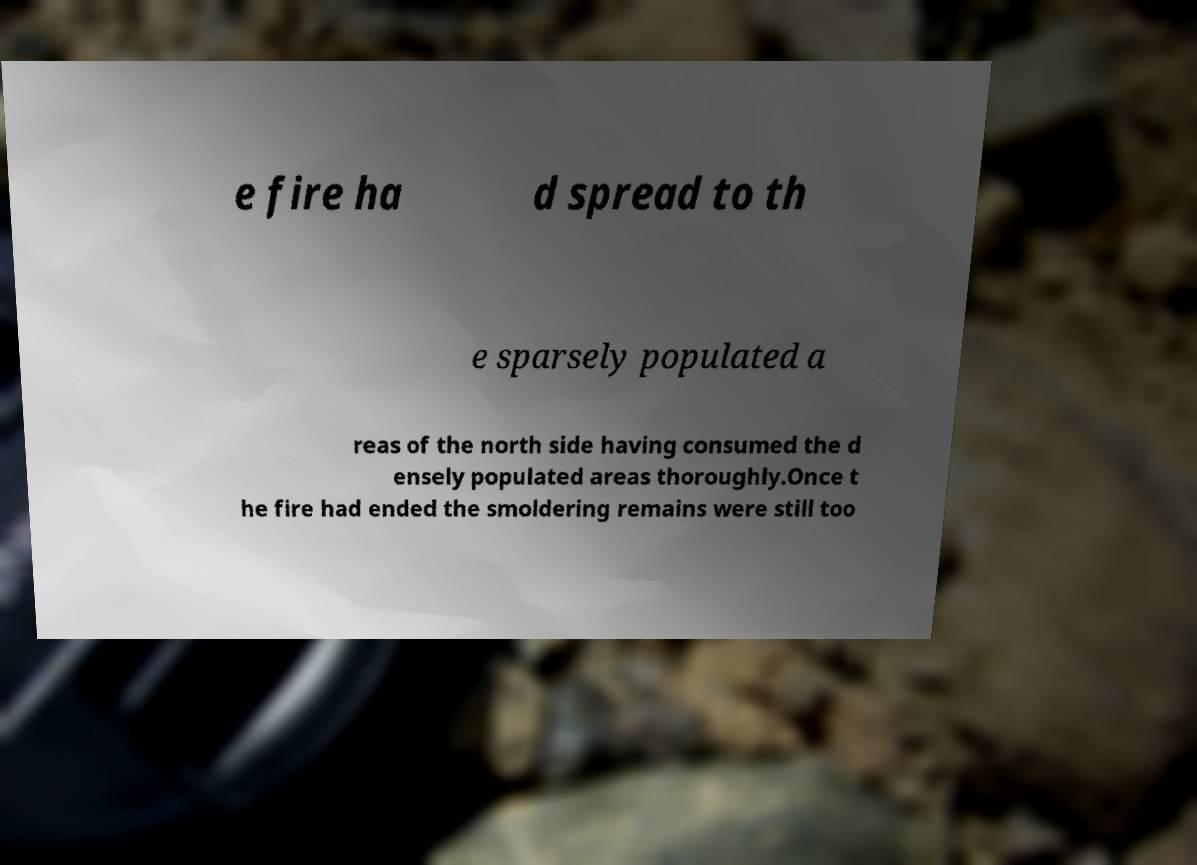What messages or text are displayed in this image? I need them in a readable, typed format. e fire ha d spread to th e sparsely populated a reas of the north side having consumed the d ensely populated areas thoroughly.Once t he fire had ended the smoldering remains were still too 